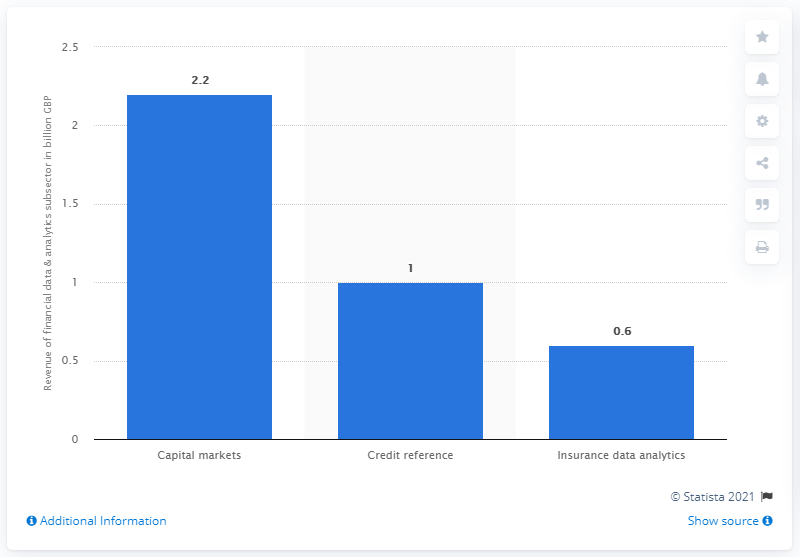Indicate a few pertinent items in this graphic. In August 2014, the data and analytics related to capital markets generated revenue of approximately 2.2. 